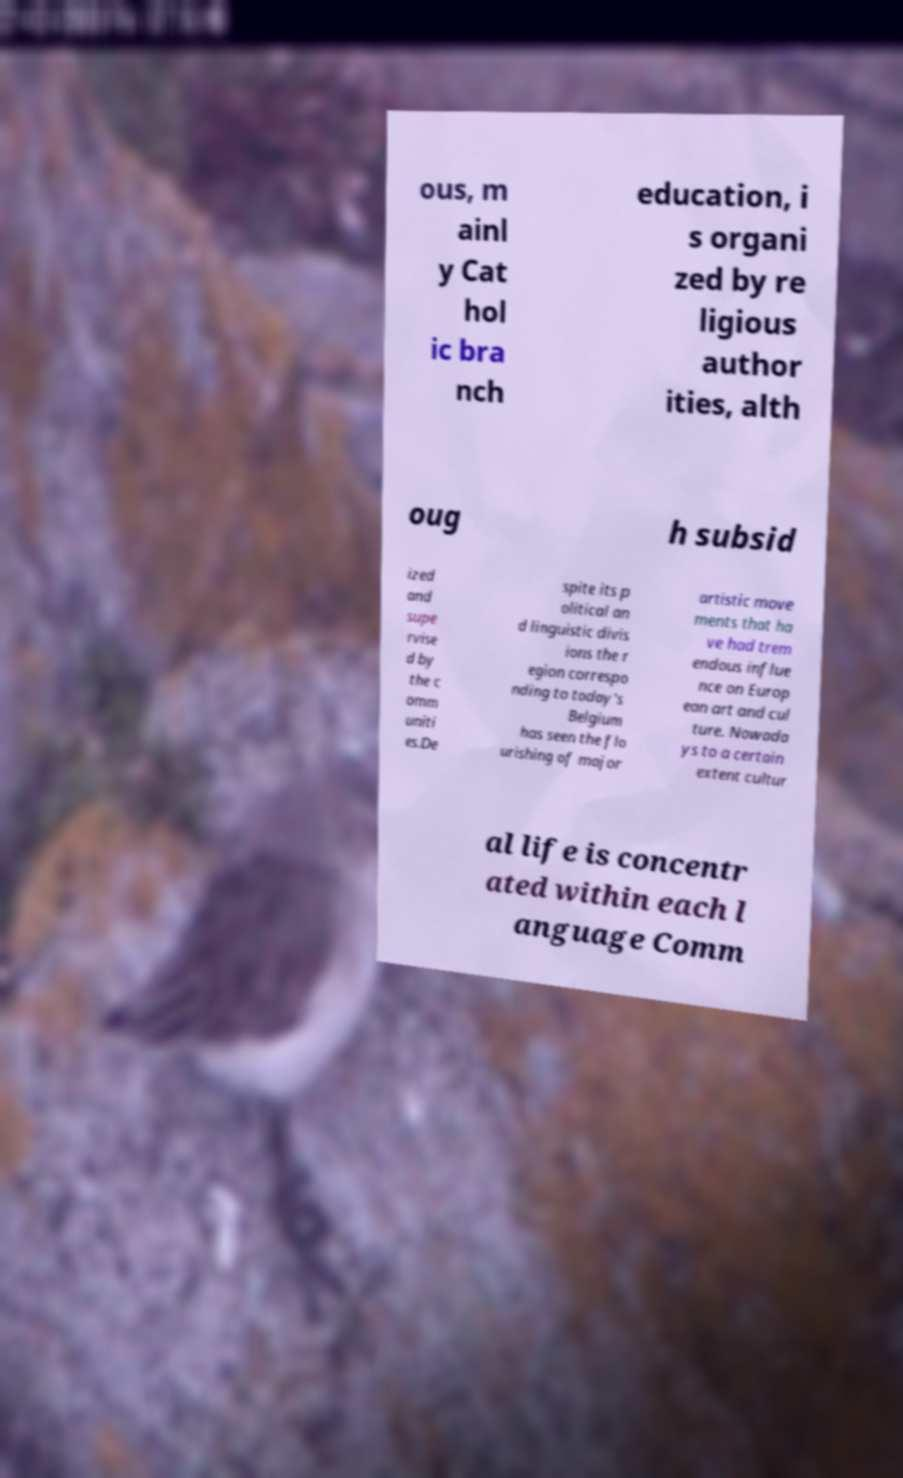Please read and relay the text visible in this image. What does it say? ous, m ainl y Cat hol ic bra nch education, i s organi zed by re ligious author ities, alth oug h subsid ized and supe rvise d by the c omm uniti es.De spite its p olitical an d linguistic divis ions the r egion correspo nding to today's Belgium has seen the flo urishing of major artistic move ments that ha ve had trem endous influe nce on Europ ean art and cul ture. Nowada ys to a certain extent cultur al life is concentr ated within each l anguage Comm 